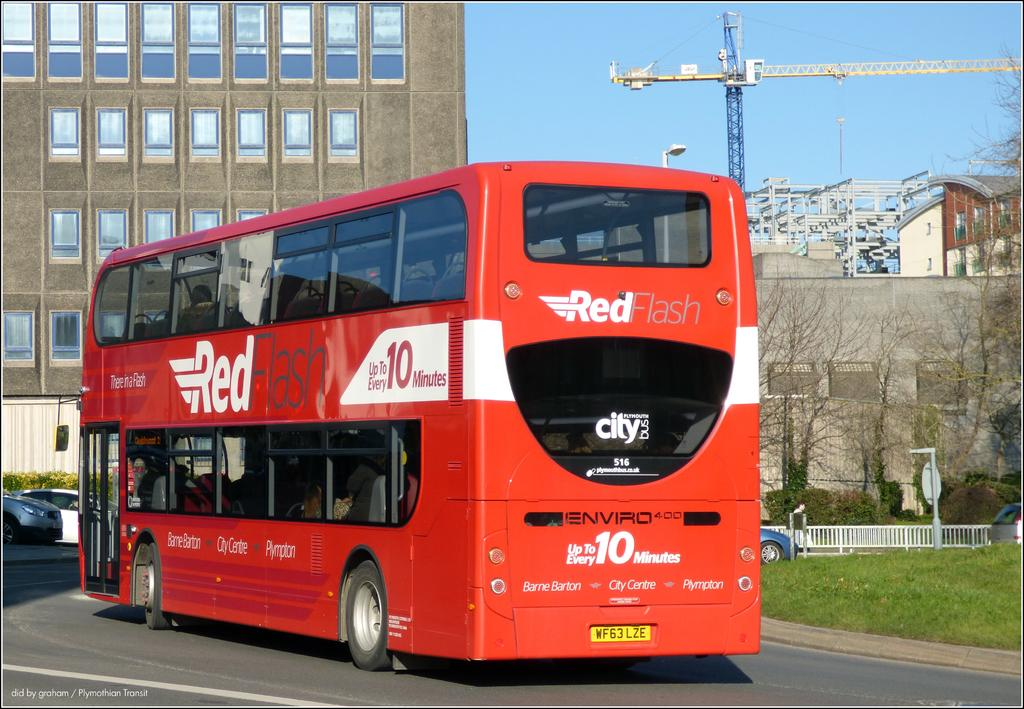<image>
Share a concise interpretation of the image provided. A Red Flash bus advertises that it arrives every 10 minutes. 